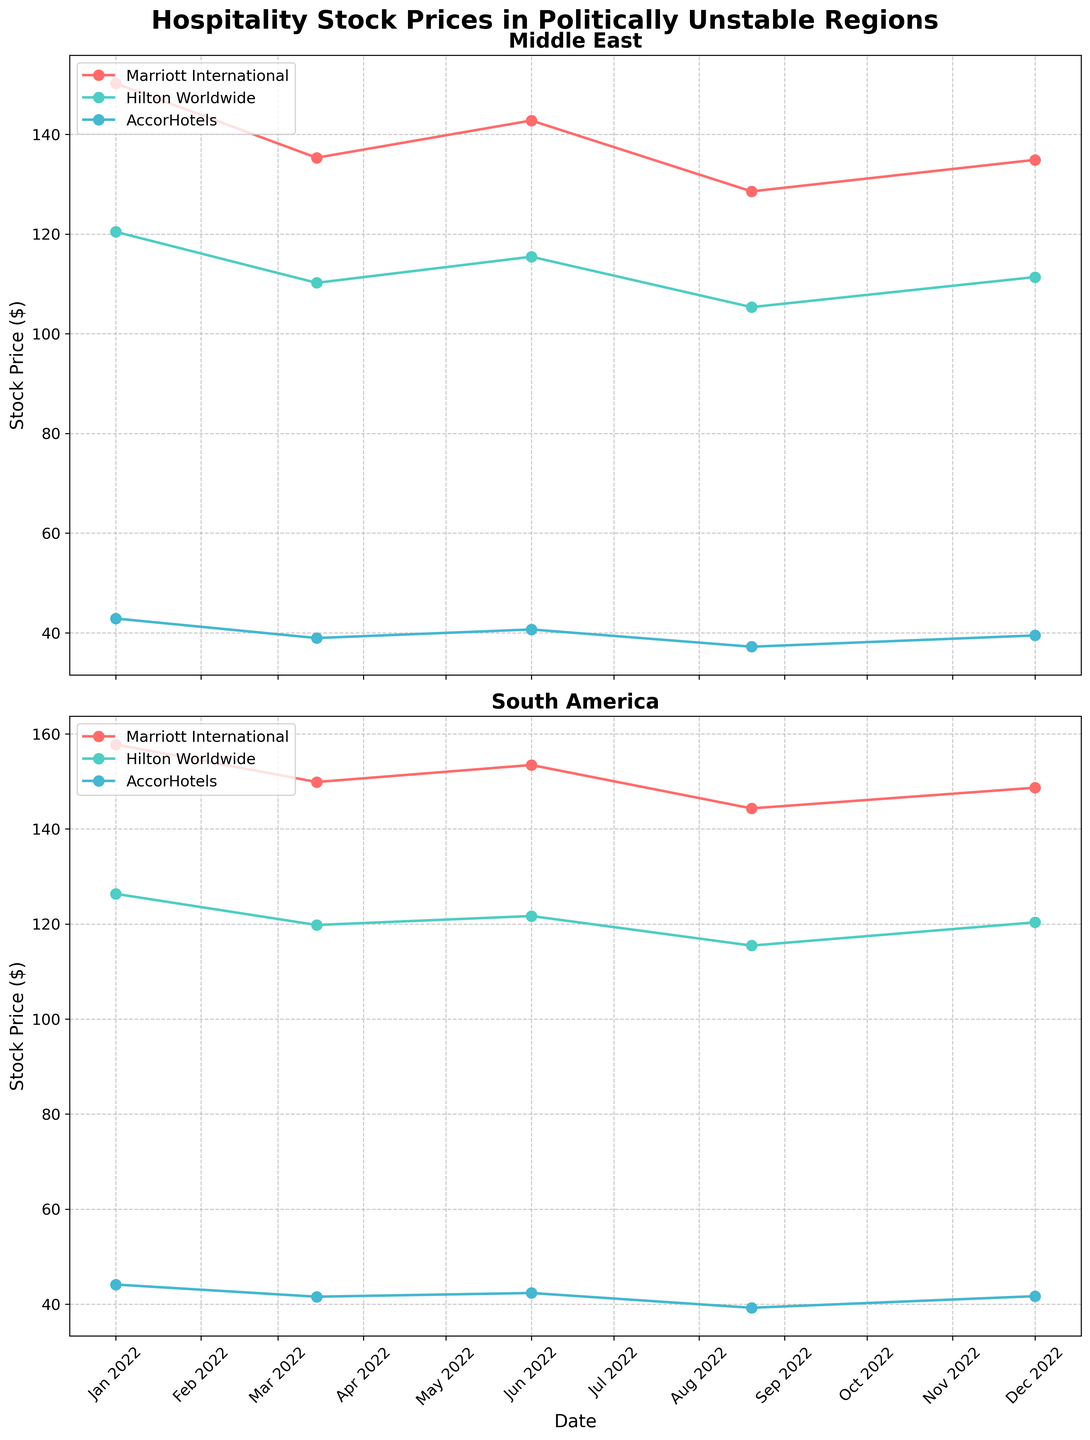What are the titles of the two subplots? The titles of the two subplots are displayed at the top of each subplot. The first subplot is titled "Middle East", and the second subplot is titled "South America".
Answer: Middle East, South America Which company's stock price is the highest in the Middle East on January 1, 2022? Refer to the first subplot labeled "Middle East". On January 1, 2022, Marriott International has the highest stock price at $150.23.
Answer: Marriott International What is the overall trend of Hilton Worldwide's stock price in the Middle East? Look at the data points connected for Hilton Worldwide in the Middle East subplot. The stock price shows a downward trend from January 2022 ($120.45) to August 2022 ($105.34) and then slightly rises by December 2022 ($111.37).
Answer: Downward trend Which region shows more volatility in stock prices for Marriott International throughout the year? Compare the range of fluctuation in Marriott International's stock prices in both subplots. The Middle East subplot shows variability from $150.23 to $128.56, while the South America subplot ranges from $157.78 to $144.32. The Middle East shows more volatility.
Answer: Middle East How does AccorHotels' stock price in South America on August 20, 2022, compare to its stock price in the Middle East on the same date? Check both subplots for August 20, 2022. In South America, AccorHotels' stock price is $39.23, while in the Middle East, it is $37.21. The stock price in South America is higher.
Answer: Higher in South America What are the average stock prices for Hilton Worldwide in the South American region for the given dates? The given dates for Hilton Worldwide in South America are: Jan 1 - $126.34, Mar 15 - $119.78, Jun 1 - $121.67, Aug 20 - $115.45, Dec 1 - $120.34. The average is calculated as ($126.34 + $119.78 + $121.67 + $115.45 + $120.34) / 5 = $120.316.
Answer: $120.316 Which company shows the least fluctuation in stock prices in the South American region? In the South America subplot, compare the range of stock price fluctuations for all three companies. AccorHotels has the smallest range, varying from $44.12 to $39.23.
Answer: AccorHotels What is the difference in Marriott International's stock price between January 1, 2022, and December 1, 2022, in the Middle East? Refer to the Marriott International plots in the Middle East subplot. The stock price on January 1, 2022, is $150.23 and on December 1, 2022, is $134.89. The difference is $150.23 - $134.89 = $15.34.
Answer: $15.34 Whose stock prices are higher overall, Marriott International or Hilton Worldwide in South America? Compare the stock prices for both companies across all given dates in South America. Marriott International consistently has higher stock prices compared to Hilton Worldwide.
Answer: Marriott International 